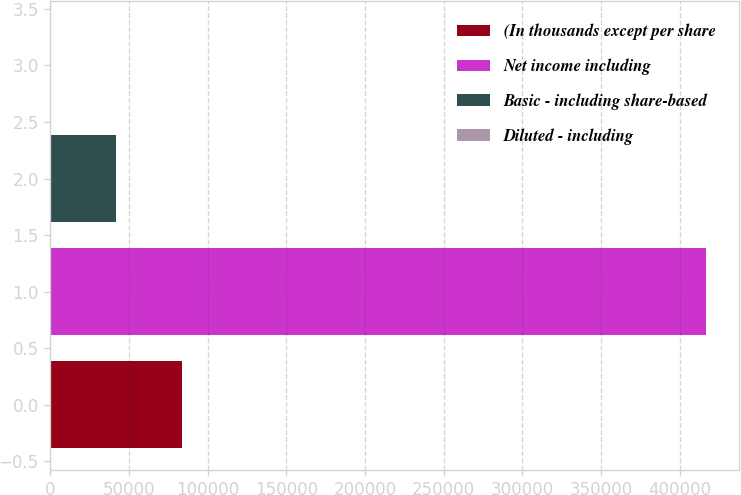Convert chart to OTSL. <chart><loc_0><loc_0><loc_500><loc_500><bar_chart><fcel>(In thousands except per share<fcel>Net income including<fcel>Basic - including share-based<fcel>Diluted - including<nl><fcel>83393.5<fcel>416963<fcel>41697.3<fcel>1.16<nl></chart> 